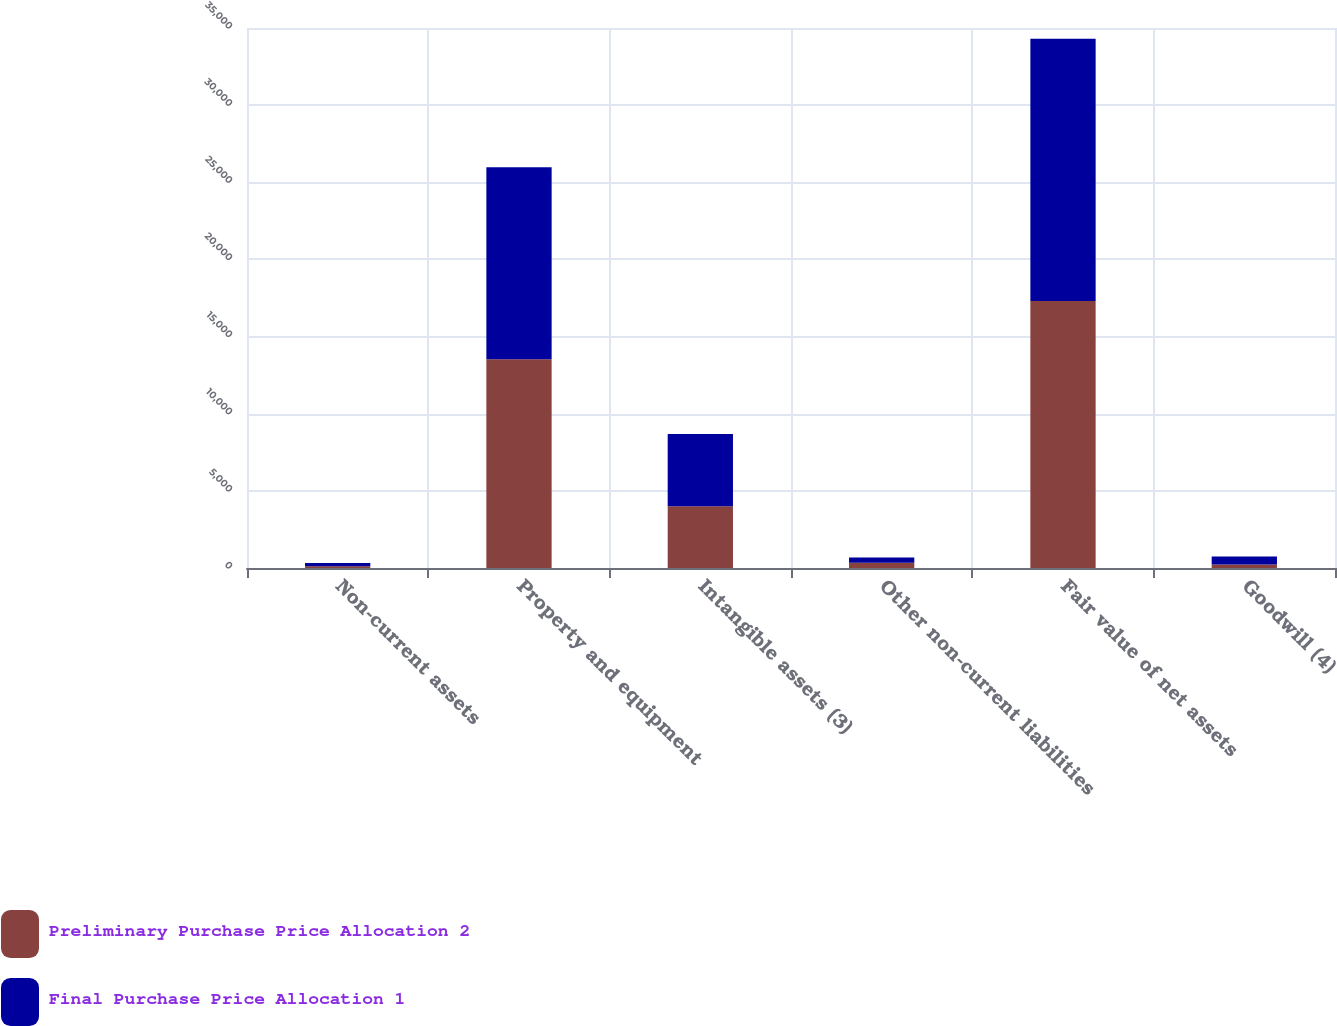Convert chart. <chart><loc_0><loc_0><loc_500><loc_500><stacked_bar_chart><ecel><fcel>Non-current assets<fcel>Property and equipment<fcel>Intangible assets (3)<fcel>Other non-current liabilities<fcel>Fair value of net assets<fcel>Goodwill (4)<nl><fcel>Preliminary Purchase Price Allocation 2<fcel>110<fcel>13526<fcel>4008<fcel>341<fcel>17303<fcel>227<nl><fcel>Final Purchase Price Allocation 1<fcel>217<fcel>12456<fcel>4675<fcel>341<fcel>17007<fcel>523<nl></chart> 